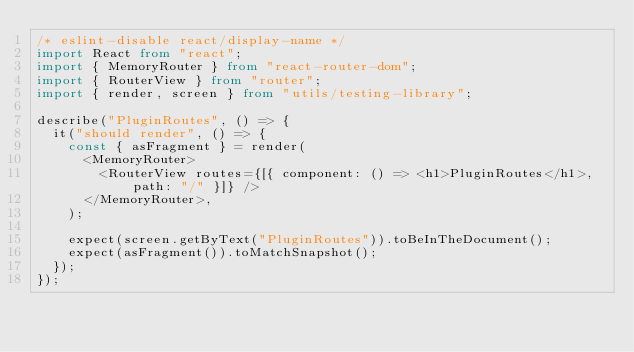Convert code to text. <code><loc_0><loc_0><loc_500><loc_500><_TypeScript_>/* eslint-disable react/display-name */
import React from "react";
import { MemoryRouter } from "react-router-dom";
import { RouterView } from "router";
import { render, screen } from "utils/testing-library";

describe("PluginRoutes", () => {
	it("should render", () => {
		const { asFragment } = render(
			<MemoryRouter>
				<RouterView routes={[{ component: () => <h1>PluginRoutes</h1>, path: "/" }]} />
			</MemoryRouter>,
		);

		expect(screen.getByText("PluginRoutes")).toBeInTheDocument();
		expect(asFragment()).toMatchSnapshot();
	});
});
</code> 